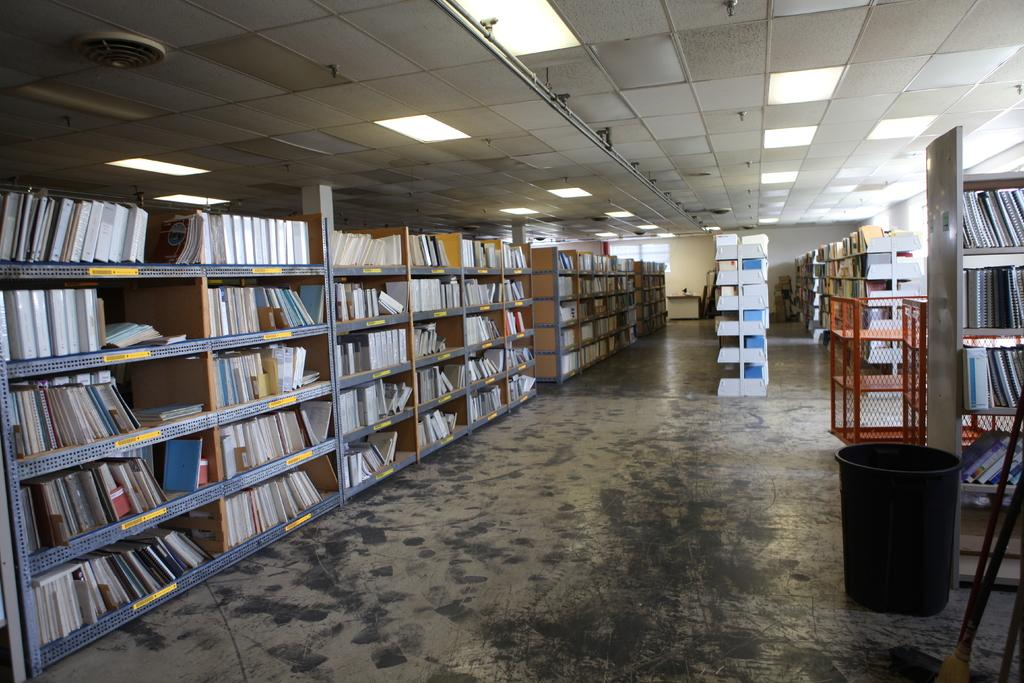Where was the image taken? The image was taken in a library. What can be seen in the library besides books? There are many racks, a basket, and a table in the library. What type of pollution can be seen in the library? There is no pollution present in the library; it is an indoor environment with books and other library-related items. 